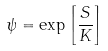Convert formula to latex. <formula><loc_0><loc_0><loc_500><loc_500>\psi = \exp \left [ \frac { S } { K } \right ]</formula> 